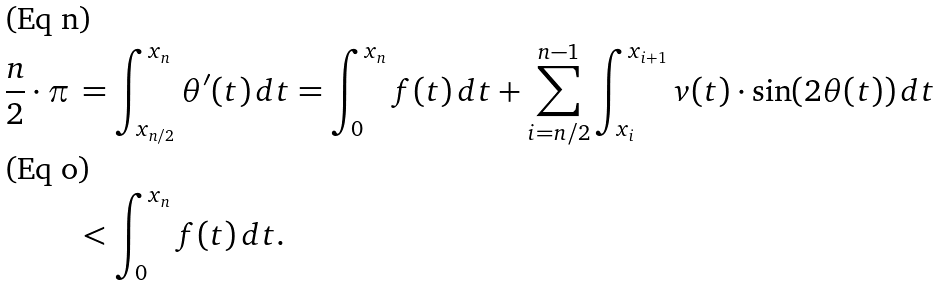<formula> <loc_0><loc_0><loc_500><loc_500>\frac { n } { 2 } \cdot \pi & \, = \int _ { x _ { n / 2 } } ^ { x _ { n } } \theta ^ { \prime } ( t ) \, d t = \int _ { 0 } ^ { x _ { n } } f ( t ) \, d t + \sum _ { i = n / 2 } ^ { n - 1 } \int _ { x _ { i } } ^ { x _ { i + 1 } } v ( t ) \cdot \sin ( 2 \theta ( t ) ) \, d t \\ & \, < \int _ { 0 } ^ { x _ { n } } f ( t ) \, d t .</formula> 